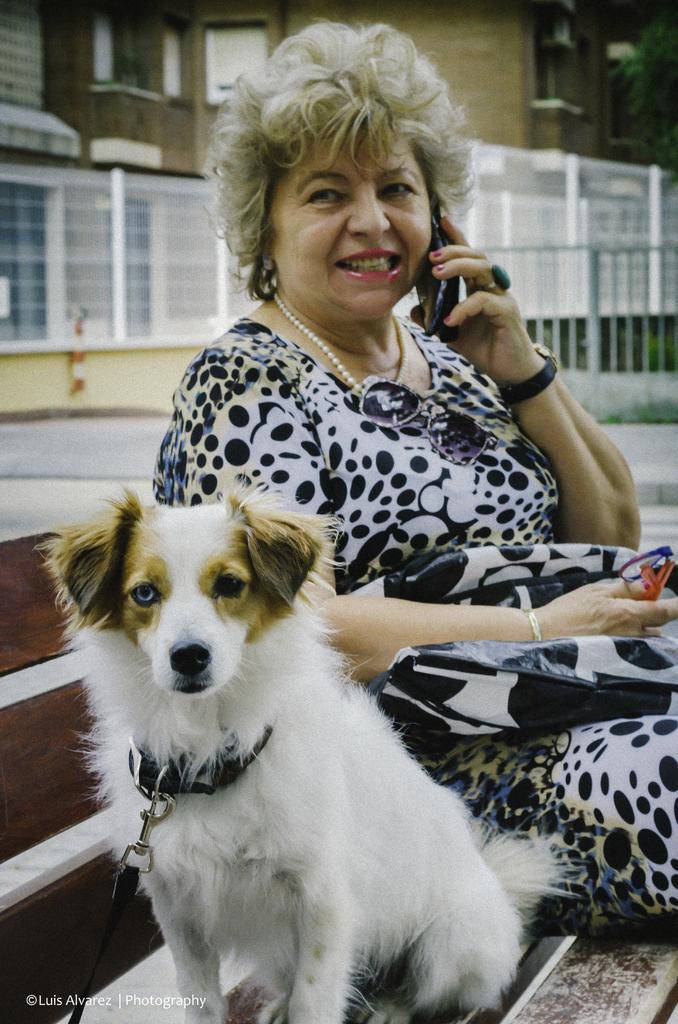How would you summarize this image in a sentence or two? In this picture I can observe a woman and dog sitting on the bench. In the background I can observe building. 